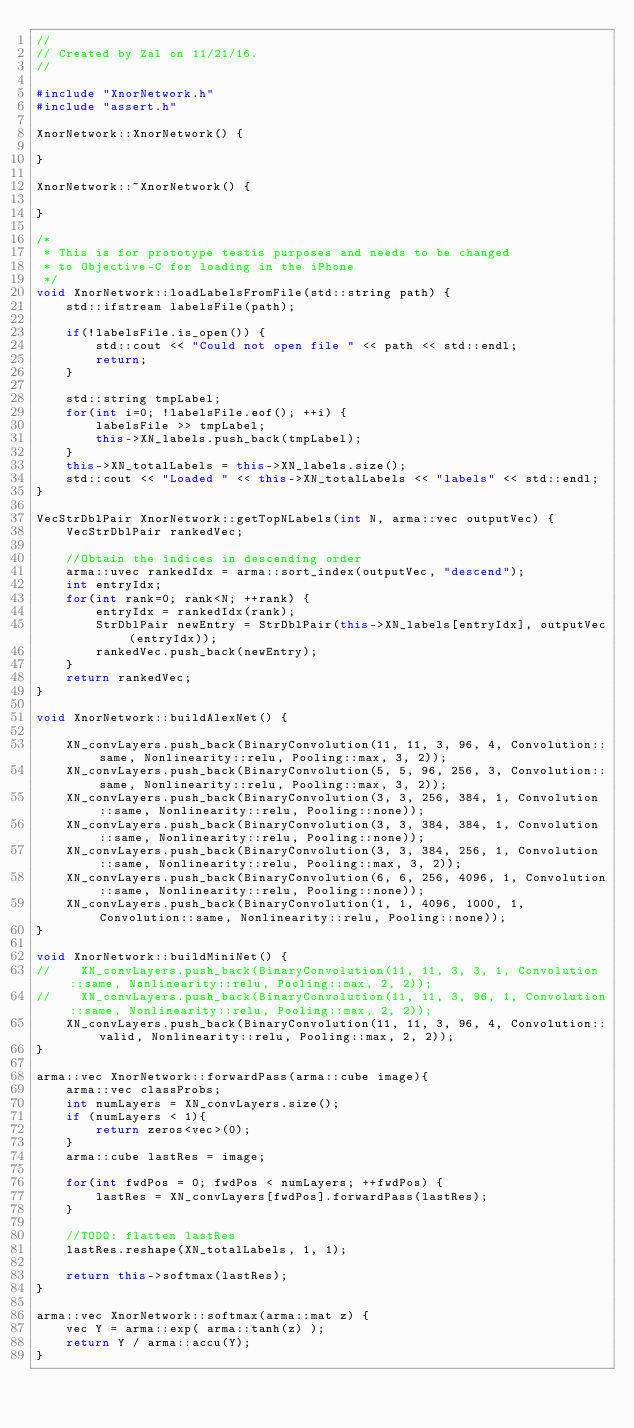<code> <loc_0><loc_0><loc_500><loc_500><_C++_>//
// Created by Zal on 11/21/16.
//

#include "XnorNetwork.h"
#include "assert.h"

XnorNetwork::XnorNetwork() {

}

XnorNetwork::~XnorNetwork() {

}

/*
 * This is for prototype testis purposes and needs to be changed
 * to Objective-C for loading in the iPhone
 */
void XnorNetwork::loadLabelsFromFile(std::string path) {
    std::ifstream labelsFile(path);

    if(!labelsFile.is_open()) {
        std::cout << "Could not open file " << path << std::endl;
        return;
    }

    std::string tmpLabel;
    for(int i=0; !labelsFile.eof(); ++i) {
        labelsFile >> tmpLabel;
        this->XN_labels.push_back(tmpLabel);
    }
    this->XN_totalLabels = this->XN_labels.size();
    std::cout << "Loaded " << this->XN_totalLabels << "labels" << std::endl;
}

VecStrDblPair XnorNetwork::getTopNLabels(int N, arma::vec outputVec) {
    VecStrDblPair rankedVec;

    //Obtain the indices in descending order
    arma::uvec rankedIdx = arma::sort_index(outputVec, "descend");
    int entryIdx;
    for(int rank=0; rank<N; ++rank) {
        entryIdx = rankedIdx(rank);
        StrDblPair newEntry = StrDblPair(this->XN_labels[entryIdx], outputVec(entryIdx));
        rankedVec.push_back(newEntry);
    }
    return rankedVec;
}

void XnorNetwork::buildAlexNet() {

    XN_convLayers.push_back(BinaryConvolution(11, 11, 3, 96, 4, Convolution::same, Nonlinearity::relu, Pooling::max, 3, 2));
    XN_convLayers.push_back(BinaryConvolution(5, 5, 96, 256, 3, Convolution::same, Nonlinearity::relu, Pooling::max, 3, 2));
    XN_convLayers.push_back(BinaryConvolution(3, 3, 256, 384, 1, Convolution::same, Nonlinearity::relu, Pooling::none));
    XN_convLayers.push_back(BinaryConvolution(3, 3, 384, 384, 1, Convolution::same, Nonlinearity::relu, Pooling::none));
    XN_convLayers.push_back(BinaryConvolution(3, 3, 384, 256, 1, Convolution::same, Nonlinearity::relu, Pooling::max, 3, 2));
    XN_convLayers.push_back(BinaryConvolution(6, 6, 256, 4096, 1, Convolution::same, Nonlinearity::relu, Pooling::none));
    XN_convLayers.push_back(BinaryConvolution(1, 1, 4096, 1000, 1, Convolution::same, Nonlinearity::relu, Pooling::none));
}

void XnorNetwork::buildMiniNet() {
//    XN_convLayers.push_back(BinaryConvolution(11, 11, 3, 3, 1, Convolution::same, Nonlinearity::relu, Pooling::max, 2, 2));
//    XN_convLayers.push_back(BinaryConvolution(11, 11, 3, 96, 1, Convolution::same, Nonlinearity::relu, Pooling::max, 2, 2));
    XN_convLayers.push_back(BinaryConvolution(11, 11, 3, 96, 4, Convolution::valid, Nonlinearity::relu, Pooling::max, 2, 2));
}

arma::vec XnorNetwork::forwardPass(arma::cube image){
    arma::vec classProbs;
    int numLayers = XN_convLayers.size();
    if (numLayers < 1){
        return zeros<vec>(0);
    }
    arma::cube lastRes = image;

    for(int fwdPos = 0; fwdPos < numLayers; ++fwdPos) {
        lastRes = XN_convLayers[fwdPos].forwardPass(lastRes);
    }

    //TODO: flatten lastRes
    lastRes.reshape(XN_totalLabels, 1, 1);

    return this->softmax(lastRes);
}

arma::vec XnorNetwork::softmax(arma::mat z) {
    vec Y = arma::exp( arma::tanh(z) );
    return Y / arma::accu(Y);
}
</code> 